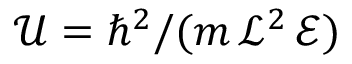Convert formula to latex. <formula><loc_0><loc_0><loc_500><loc_500>{ { \mathcal { U } } = \hbar { ^ } { 2 } / ( m \, \mathcal { L } ^ { 2 } \, \mathcal { E } ) }</formula> 